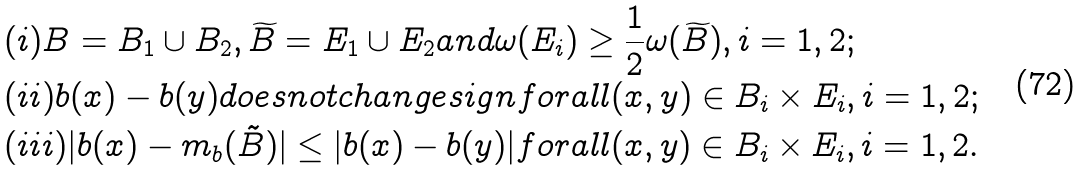<formula> <loc_0><loc_0><loc_500><loc_500>& ( i ) B = B _ { 1 } \cup B _ { 2 } , \widetilde { B } = E _ { 1 } \cup E _ { 2 } a n d \omega ( E _ { i } ) \geq \frac { 1 } { 2 } \omega ( \widetilde { B } ) , i = 1 , 2 ; \\ & ( i i ) b ( x ) - b ( y ) d o e s n o t c h a n g e s i g n f o r a l l ( x , y ) \in B _ { i } \times E _ { i } , i = 1 , 2 ; \\ & ( i i i ) | b ( x ) - m _ { b } ( \tilde { B } ) | \leq | b ( x ) - b ( y ) | f o r a l l ( x , y ) \in B _ { i } \times E _ { i } , i = 1 , 2 .</formula> 